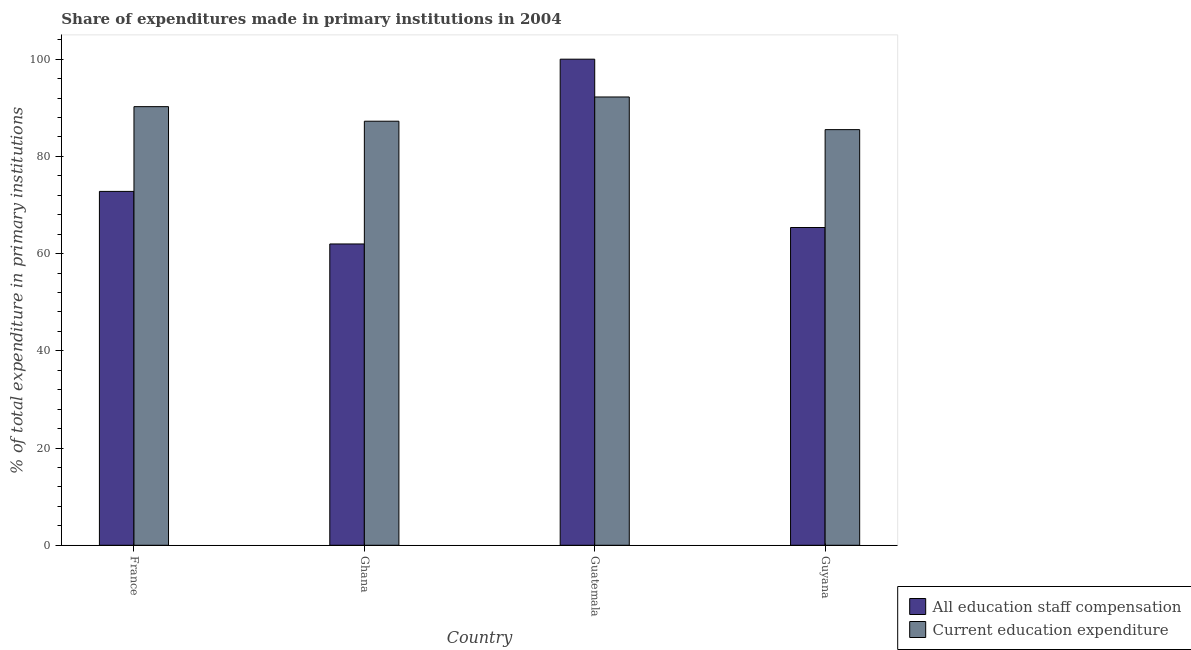How many different coloured bars are there?
Offer a very short reply. 2. How many groups of bars are there?
Provide a short and direct response. 4. Are the number of bars per tick equal to the number of legend labels?
Give a very brief answer. Yes. Are the number of bars on each tick of the X-axis equal?
Give a very brief answer. Yes. How many bars are there on the 1st tick from the right?
Keep it short and to the point. 2. What is the label of the 4th group of bars from the left?
Offer a terse response. Guyana. In how many cases, is the number of bars for a given country not equal to the number of legend labels?
Provide a succinct answer. 0. What is the expenditure in education in Guatemala?
Your response must be concise. 92.22. Across all countries, what is the maximum expenditure in staff compensation?
Give a very brief answer. 100. Across all countries, what is the minimum expenditure in staff compensation?
Provide a short and direct response. 61.99. In which country was the expenditure in staff compensation maximum?
Your answer should be very brief. Guatemala. In which country was the expenditure in staff compensation minimum?
Offer a terse response. Ghana. What is the total expenditure in education in the graph?
Provide a short and direct response. 355.21. What is the difference between the expenditure in staff compensation in France and that in Guyana?
Keep it short and to the point. 7.43. What is the difference between the expenditure in staff compensation in Guyana and the expenditure in education in France?
Offer a terse response. -24.87. What is the average expenditure in education per country?
Make the answer very short. 88.8. What is the difference between the expenditure in education and expenditure in staff compensation in Ghana?
Ensure brevity in your answer.  25.25. What is the ratio of the expenditure in staff compensation in Ghana to that in Guyana?
Your answer should be very brief. 0.95. Is the expenditure in education in Ghana less than that in Guyana?
Offer a very short reply. No. Is the difference between the expenditure in staff compensation in Guatemala and Guyana greater than the difference between the expenditure in education in Guatemala and Guyana?
Provide a short and direct response. Yes. What is the difference between the highest and the second highest expenditure in education?
Provide a short and direct response. 1.99. What is the difference between the highest and the lowest expenditure in education?
Provide a short and direct response. 6.72. What does the 2nd bar from the left in Guatemala represents?
Your answer should be very brief. Current education expenditure. What does the 1st bar from the right in Guyana represents?
Your response must be concise. Current education expenditure. How many bars are there?
Offer a terse response. 8. Are all the bars in the graph horizontal?
Make the answer very short. No. How many countries are there in the graph?
Provide a succinct answer. 4. Does the graph contain any zero values?
Offer a terse response. No. Where does the legend appear in the graph?
Provide a short and direct response. Bottom right. What is the title of the graph?
Make the answer very short. Share of expenditures made in primary institutions in 2004. Does "Investment in Transport" appear as one of the legend labels in the graph?
Your answer should be compact. No. What is the label or title of the Y-axis?
Offer a very short reply. % of total expenditure in primary institutions. What is the % of total expenditure in primary institutions in All education staff compensation in France?
Give a very brief answer. 72.8. What is the % of total expenditure in primary institutions in Current education expenditure in France?
Your response must be concise. 90.24. What is the % of total expenditure in primary institutions of All education staff compensation in Ghana?
Ensure brevity in your answer.  61.99. What is the % of total expenditure in primary institutions in Current education expenditure in Ghana?
Your answer should be compact. 87.24. What is the % of total expenditure in primary institutions in All education staff compensation in Guatemala?
Your answer should be compact. 100. What is the % of total expenditure in primary institutions in Current education expenditure in Guatemala?
Offer a terse response. 92.22. What is the % of total expenditure in primary institutions in All education staff compensation in Guyana?
Offer a terse response. 65.37. What is the % of total expenditure in primary institutions in Current education expenditure in Guyana?
Provide a succinct answer. 85.51. Across all countries, what is the maximum % of total expenditure in primary institutions in All education staff compensation?
Your response must be concise. 100. Across all countries, what is the maximum % of total expenditure in primary institutions of Current education expenditure?
Ensure brevity in your answer.  92.22. Across all countries, what is the minimum % of total expenditure in primary institutions in All education staff compensation?
Give a very brief answer. 61.99. Across all countries, what is the minimum % of total expenditure in primary institutions in Current education expenditure?
Keep it short and to the point. 85.51. What is the total % of total expenditure in primary institutions in All education staff compensation in the graph?
Make the answer very short. 300.16. What is the total % of total expenditure in primary institutions of Current education expenditure in the graph?
Provide a succinct answer. 355.21. What is the difference between the % of total expenditure in primary institutions in All education staff compensation in France and that in Ghana?
Offer a terse response. 10.82. What is the difference between the % of total expenditure in primary institutions in Current education expenditure in France and that in Ghana?
Your answer should be compact. 3. What is the difference between the % of total expenditure in primary institutions in All education staff compensation in France and that in Guatemala?
Your answer should be very brief. -27.2. What is the difference between the % of total expenditure in primary institutions in Current education expenditure in France and that in Guatemala?
Ensure brevity in your answer.  -1.99. What is the difference between the % of total expenditure in primary institutions in All education staff compensation in France and that in Guyana?
Provide a short and direct response. 7.43. What is the difference between the % of total expenditure in primary institutions of Current education expenditure in France and that in Guyana?
Your answer should be very brief. 4.73. What is the difference between the % of total expenditure in primary institutions of All education staff compensation in Ghana and that in Guatemala?
Your answer should be very brief. -38.01. What is the difference between the % of total expenditure in primary institutions in Current education expenditure in Ghana and that in Guatemala?
Make the answer very short. -4.99. What is the difference between the % of total expenditure in primary institutions of All education staff compensation in Ghana and that in Guyana?
Your response must be concise. -3.38. What is the difference between the % of total expenditure in primary institutions of Current education expenditure in Ghana and that in Guyana?
Your response must be concise. 1.73. What is the difference between the % of total expenditure in primary institutions of All education staff compensation in Guatemala and that in Guyana?
Offer a terse response. 34.63. What is the difference between the % of total expenditure in primary institutions of Current education expenditure in Guatemala and that in Guyana?
Make the answer very short. 6.72. What is the difference between the % of total expenditure in primary institutions of All education staff compensation in France and the % of total expenditure in primary institutions of Current education expenditure in Ghana?
Make the answer very short. -14.44. What is the difference between the % of total expenditure in primary institutions in All education staff compensation in France and the % of total expenditure in primary institutions in Current education expenditure in Guatemala?
Offer a very short reply. -19.42. What is the difference between the % of total expenditure in primary institutions in All education staff compensation in France and the % of total expenditure in primary institutions in Current education expenditure in Guyana?
Offer a terse response. -12.71. What is the difference between the % of total expenditure in primary institutions of All education staff compensation in Ghana and the % of total expenditure in primary institutions of Current education expenditure in Guatemala?
Your response must be concise. -30.24. What is the difference between the % of total expenditure in primary institutions in All education staff compensation in Ghana and the % of total expenditure in primary institutions in Current education expenditure in Guyana?
Provide a succinct answer. -23.52. What is the difference between the % of total expenditure in primary institutions in All education staff compensation in Guatemala and the % of total expenditure in primary institutions in Current education expenditure in Guyana?
Provide a succinct answer. 14.49. What is the average % of total expenditure in primary institutions in All education staff compensation per country?
Offer a terse response. 75.04. What is the average % of total expenditure in primary institutions of Current education expenditure per country?
Make the answer very short. 88.8. What is the difference between the % of total expenditure in primary institutions of All education staff compensation and % of total expenditure in primary institutions of Current education expenditure in France?
Offer a terse response. -17.44. What is the difference between the % of total expenditure in primary institutions of All education staff compensation and % of total expenditure in primary institutions of Current education expenditure in Ghana?
Your answer should be very brief. -25.25. What is the difference between the % of total expenditure in primary institutions in All education staff compensation and % of total expenditure in primary institutions in Current education expenditure in Guatemala?
Give a very brief answer. 7.78. What is the difference between the % of total expenditure in primary institutions of All education staff compensation and % of total expenditure in primary institutions of Current education expenditure in Guyana?
Your response must be concise. -20.14. What is the ratio of the % of total expenditure in primary institutions of All education staff compensation in France to that in Ghana?
Your answer should be compact. 1.17. What is the ratio of the % of total expenditure in primary institutions of Current education expenditure in France to that in Ghana?
Make the answer very short. 1.03. What is the ratio of the % of total expenditure in primary institutions in All education staff compensation in France to that in Guatemala?
Offer a very short reply. 0.73. What is the ratio of the % of total expenditure in primary institutions of Current education expenditure in France to that in Guatemala?
Give a very brief answer. 0.98. What is the ratio of the % of total expenditure in primary institutions of All education staff compensation in France to that in Guyana?
Give a very brief answer. 1.11. What is the ratio of the % of total expenditure in primary institutions of Current education expenditure in France to that in Guyana?
Provide a succinct answer. 1.06. What is the ratio of the % of total expenditure in primary institutions in All education staff compensation in Ghana to that in Guatemala?
Offer a terse response. 0.62. What is the ratio of the % of total expenditure in primary institutions in Current education expenditure in Ghana to that in Guatemala?
Provide a succinct answer. 0.95. What is the ratio of the % of total expenditure in primary institutions of All education staff compensation in Ghana to that in Guyana?
Your answer should be compact. 0.95. What is the ratio of the % of total expenditure in primary institutions in Current education expenditure in Ghana to that in Guyana?
Offer a very short reply. 1.02. What is the ratio of the % of total expenditure in primary institutions in All education staff compensation in Guatemala to that in Guyana?
Your answer should be very brief. 1.53. What is the ratio of the % of total expenditure in primary institutions in Current education expenditure in Guatemala to that in Guyana?
Your answer should be very brief. 1.08. What is the difference between the highest and the second highest % of total expenditure in primary institutions of All education staff compensation?
Your answer should be very brief. 27.2. What is the difference between the highest and the second highest % of total expenditure in primary institutions of Current education expenditure?
Offer a terse response. 1.99. What is the difference between the highest and the lowest % of total expenditure in primary institutions in All education staff compensation?
Offer a very short reply. 38.01. What is the difference between the highest and the lowest % of total expenditure in primary institutions of Current education expenditure?
Give a very brief answer. 6.72. 